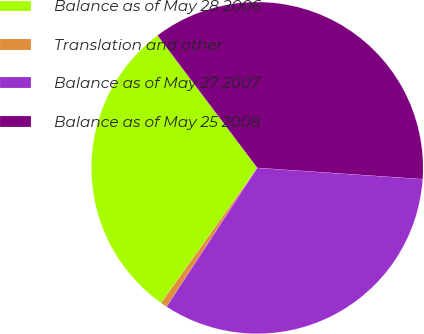Convert chart to OTSL. <chart><loc_0><loc_0><loc_500><loc_500><pie_chart><fcel>Balance as of May 28 2006<fcel>Translation and other<fcel>Balance as of May 27 2007<fcel>Balance as of May 25 2008<nl><fcel>29.88%<fcel>0.64%<fcel>33.12%<fcel>36.36%<nl></chart> 